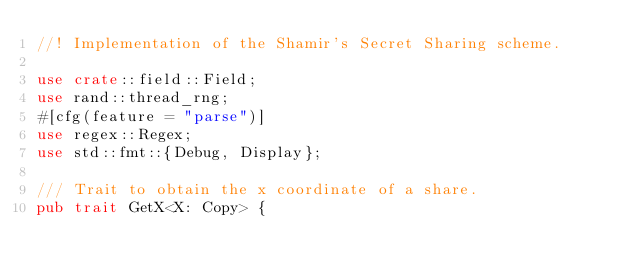Convert code to text. <code><loc_0><loc_0><loc_500><loc_500><_Rust_>//! Implementation of the Shamir's Secret Sharing scheme.

use crate::field::Field;
use rand::thread_rng;
#[cfg(feature = "parse")]
use regex::Regex;
use std::fmt::{Debug, Display};

/// Trait to obtain the x coordinate of a share.
pub trait GetX<X: Copy> {</code> 